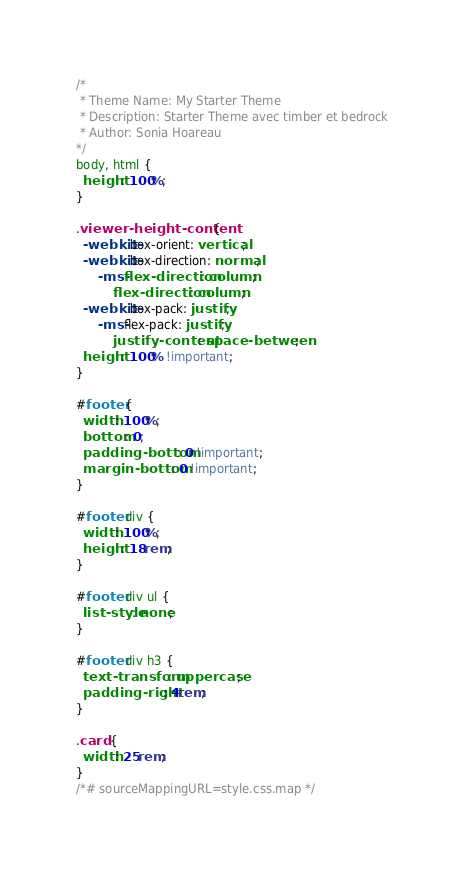<code> <loc_0><loc_0><loc_500><loc_500><_CSS_>/*
 * Theme Name: My Starter Theme
 * Description: Starter Theme avec timber et bedrock
 * Author: Sonia Hoareau
*/
body, html {
  height: 100%;
}

.viewer-height-content {
  -webkit-box-orient: vertical;
  -webkit-box-direction: normal;
      -ms-flex-direction: column;
          flex-direction: column;
  -webkit-box-pack: justify;
      -ms-flex-pack: justify;
          justify-content: space-between;
  height: 100% !important;
}

#footer {
  width: 100%;
  bottom: 0;
  padding-bottom: 0 !important;
  margin-bottom: 0 !important;
}

#footer div {
  width: 100%;
  height: 18rem;
}

#footer div ul {
  list-style: none;
}

#footer div h3 {
  text-transform: uppercase;
  padding-right: 4rem;
}

.card {
  width: 25rem;
}
/*# sourceMappingURL=style.css.map */</code> 